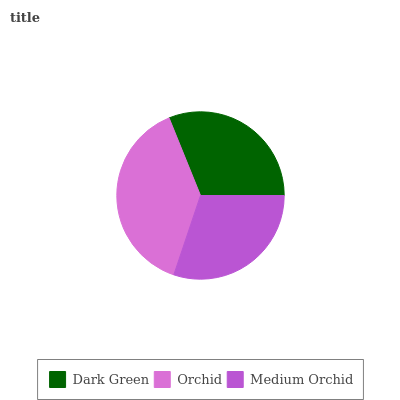Is Medium Orchid the minimum?
Answer yes or no. Yes. Is Orchid the maximum?
Answer yes or no. Yes. Is Orchid the minimum?
Answer yes or no. No. Is Medium Orchid the maximum?
Answer yes or no. No. Is Orchid greater than Medium Orchid?
Answer yes or no. Yes. Is Medium Orchid less than Orchid?
Answer yes or no. Yes. Is Medium Orchid greater than Orchid?
Answer yes or no. No. Is Orchid less than Medium Orchid?
Answer yes or no. No. Is Dark Green the high median?
Answer yes or no. Yes. Is Dark Green the low median?
Answer yes or no. Yes. Is Orchid the high median?
Answer yes or no. No. Is Orchid the low median?
Answer yes or no. No. 